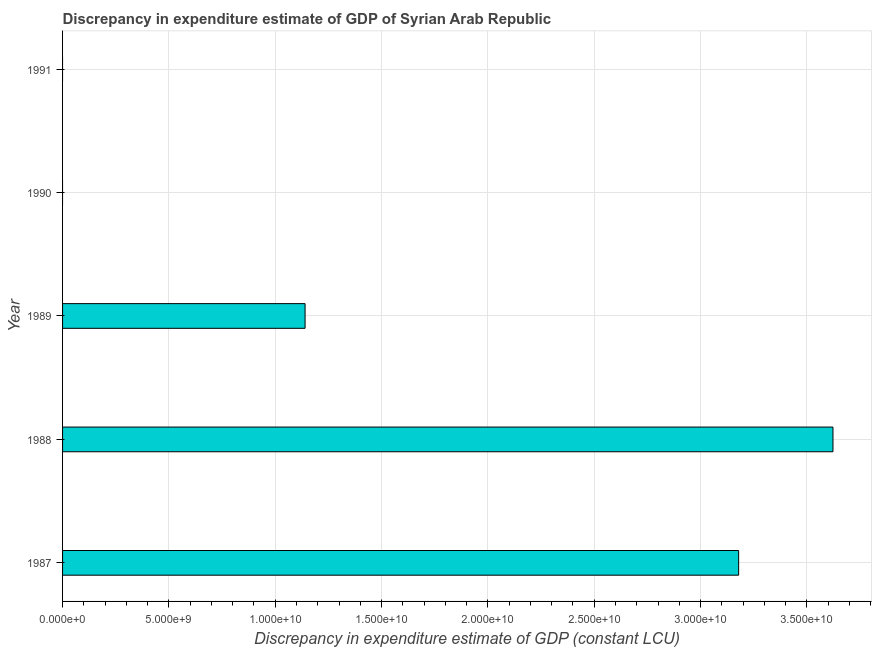Does the graph contain any zero values?
Make the answer very short. Yes. Does the graph contain grids?
Provide a succinct answer. Yes. What is the title of the graph?
Keep it short and to the point. Discrepancy in expenditure estimate of GDP of Syrian Arab Republic. What is the label or title of the X-axis?
Make the answer very short. Discrepancy in expenditure estimate of GDP (constant LCU). What is the label or title of the Y-axis?
Make the answer very short. Year. Across all years, what is the maximum discrepancy in expenditure estimate of gdp?
Your response must be concise. 3.62e+1. Across all years, what is the minimum discrepancy in expenditure estimate of gdp?
Your response must be concise. 0. What is the sum of the discrepancy in expenditure estimate of gdp?
Your answer should be very brief. 7.94e+1. What is the difference between the discrepancy in expenditure estimate of gdp in 1988 and 1989?
Your response must be concise. 2.48e+1. What is the average discrepancy in expenditure estimate of gdp per year?
Provide a short and direct response. 1.59e+1. What is the median discrepancy in expenditure estimate of gdp?
Make the answer very short. 1.14e+1. What is the ratio of the discrepancy in expenditure estimate of gdp in 1987 to that in 1988?
Provide a short and direct response. 0.88. What is the difference between the highest and the second highest discrepancy in expenditure estimate of gdp?
Ensure brevity in your answer.  4.44e+09. What is the difference between the highest and the lowest discrepancy in expenditure estimate of gdp?
Make the answer very short. 3.62e+1. In how many years, is the discrepancy in expenditure estimate of gdp greater than the average discrepancy in expenditure estimate of gdp taken over all years?
Keep it short and to the point. 2. How many bars are there?
Keep it short and to the point. 3. How many years are there in the graph?
Your response must be concise. 5. Are the values on the major ticks of X-axis written in scientific E-notation?
Make the answer very short. Yes. What is the Discrepancy in expenditure estimate of GDP (constant LCU) in 1987?
Your answer should be very brief. 3.18e+1. What is the Discrepancy in expenditure estimate of GDP (constant LCU) in 1988?
Your answer should be very brief. 3.62e+1. What is the Discrepancy in expenditure estimate of GDP (constant LCU) of 1989?
Keep it short and to the point. 1.14e+1. What is the Discrepancy in expenditure estimate of GDP (constant LCU) of 1991?
Ensure brevity in your answer.  0. What is the difference between the Discrepancy in expenditure estimate of GDP (constant LCU) in 1987 and 1988?
Provide a succinct answer. -4.44e+09. What is the difference between the Discrepancy in expenditure estimate of GDP (constant LCU) in 1987 and 1989?
Offer a terse response. 2.04e+1. What is the difference between the Discrepancy in expenditure estimate of GDP (constant LCU) in 1988 and 1989?
Your answer should be compact. 2.48e+1. What is the ratio of the Discrepancy in expenditure estimate of GDP (constant LCU) in 1987 to that in 1988?
Offer a terse response. 0.88. What is the ratio of the Discrepancy in expenditure estimate of GDP (constant LCU) in 1987 to that in 1989?
Your answer should be compact. 2.79. What is the ratio of the Discrepancy in expenditure estimate of GDP (constant LCU) in 1988 to that in 1989?
Offer a very short reply. 3.18. 